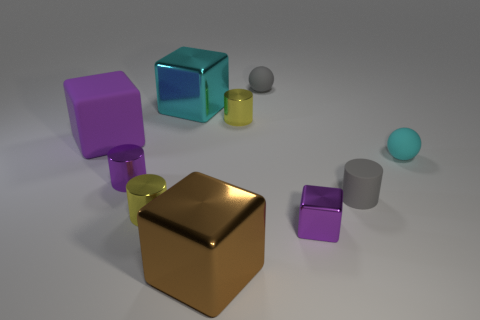Subtract all cylinders. How many objects are left? 6 Subtract all large cyan matte spheres. Subtract all small gray objects. How many objects are left? 8 Add 2 small gray matte spheres. How many small gray matte spheres are left? 3 Add 7 cyan cubes. How many cyan cubes exist? 8 Subtract 1 purple cylinders. How many objects are left? 9 